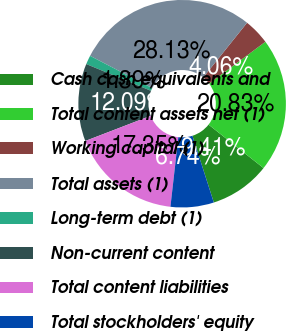Convert chart to OTSL. <chart><loc_0><loc_0><loc_500><loc_500><pie_chart><fcel>Cash cash equivalents and<fcel>Total content assets net (1)<fcel>Working capital (1)<fcel>Total assets (1)<fcel>Long-term debt (1)<fcel>Non-current content<fcel>Total content liabilities<fcel>Total stockholders' equity<nl><fcel>9.41%<fcel>20.83%<fcel>4.06%<fcel>28.13%<fcel>1.39%<fcel>12.09%<fcel>17.35%<fcel>6.74%<nl></chart> 